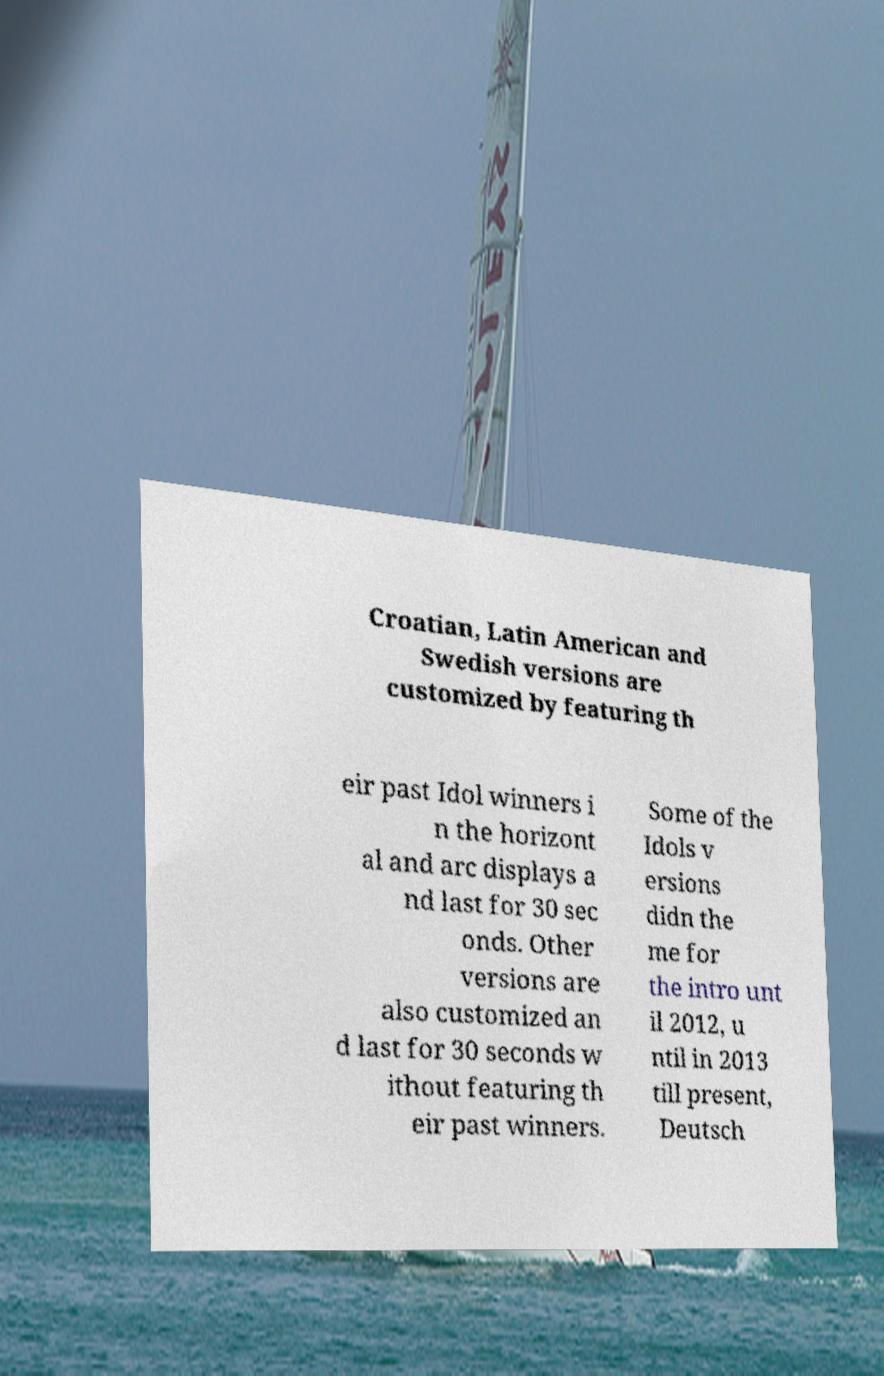For documentation purposes, I need the text within this image transcribed. Could you provide that? Croatian, Latin American and Swedish versions are customized by featuring th eir past Idol winners i n the horizont al and arc displays a nd last for 30 sec onds. Other versions are also customized an d last for 30 seconds w ithout featuring th eir past winners. Some of the Idols v ersions didn the me for the intro unt il 2012, u ntil in 2013 till present, Deutsch 